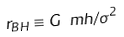Convert formula to latex. <formula><loc_0><loc_0><loc_500><loc_500>r _ { B H } \equiv G \ m h / \sigma ^ { 2 }</formula> 